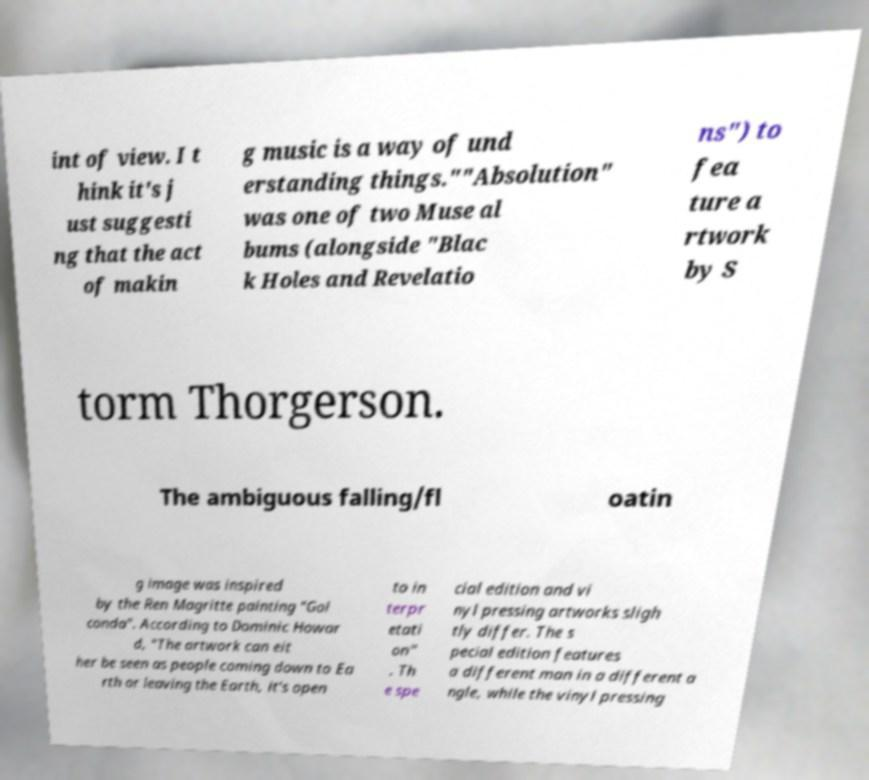Can you accurately transcribe the text from the provided image for me? int of view. I t hink it's j ust suggesti ng that the act of makin g music is a way of und erstanding things.""Absolution" was one of two Muse al bums (alongside "Blac k Holes and Revelatio ns") to fea ture a rtwork by S torm Thorgerson. The ambiguous falling/fl oatin g image was inspired by the Ren Magritte painting "Gol conda". According to Dominic Howar d, "The artwork can eit her be seen as people coming down to Ea rth or leaving the Earth, it's open to in terpr etati on" . Th e spe cial edition and vi nyl pressing artworks sligh tly differ. The s pecial edition features a different man in a different a ngle, while the vinyl pressing 